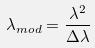Convert formula to latex. <formula><loc_0><loc_0><loc_500><loc_500>\lambda _ { m o d } = \frac { \lambda ^ { 2 } } { \Delta \lambda }</formula> 